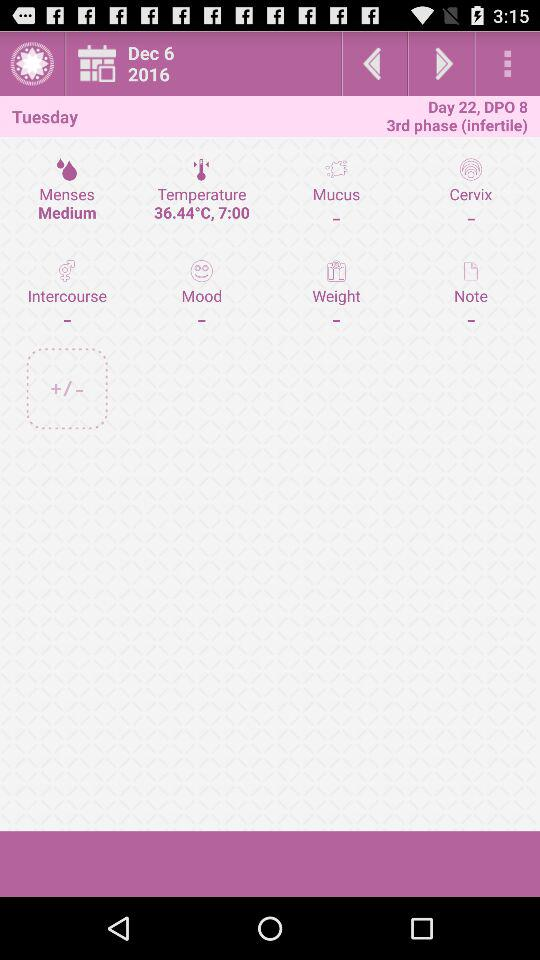What is the date on which the temperature was measured? The date on which the temperature was measured is December 6, 2016. 